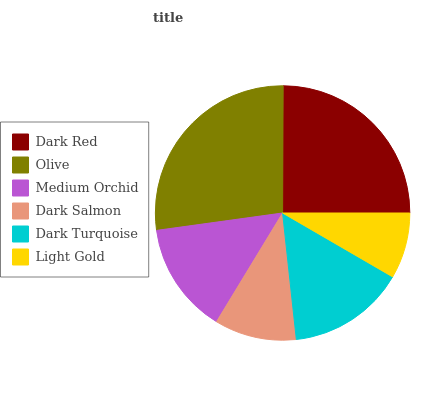Is Light Gold the minimum?
Answer yes or no. Yes. Is Olive the maximum?
Answer yes or no. Yes. Is Medium Orchid the minimum?
Answer yes or no. No. Is Medium Orchid the maximum?
Answer yes or no. No. Is Olive greater than Medium Orchid?
Answer yes or no. Yes. Is Medium Orchid less than Olive?
Answer yes or no. Yes. Is Medium Orchid greater than Olive?
Answer yes or no. No. Is Olive less than Medium Orchid?
Answer yes or no. No. Is Dark Turquoise the high median?
Answer yes or no. Yes. Is Medium Orchid the low median?
Answer yes or no. Yes. Is Light Gold the high median?
Answer yes or no. No. Is Dark Turquoise the low median?
Answer yes or no. No. 